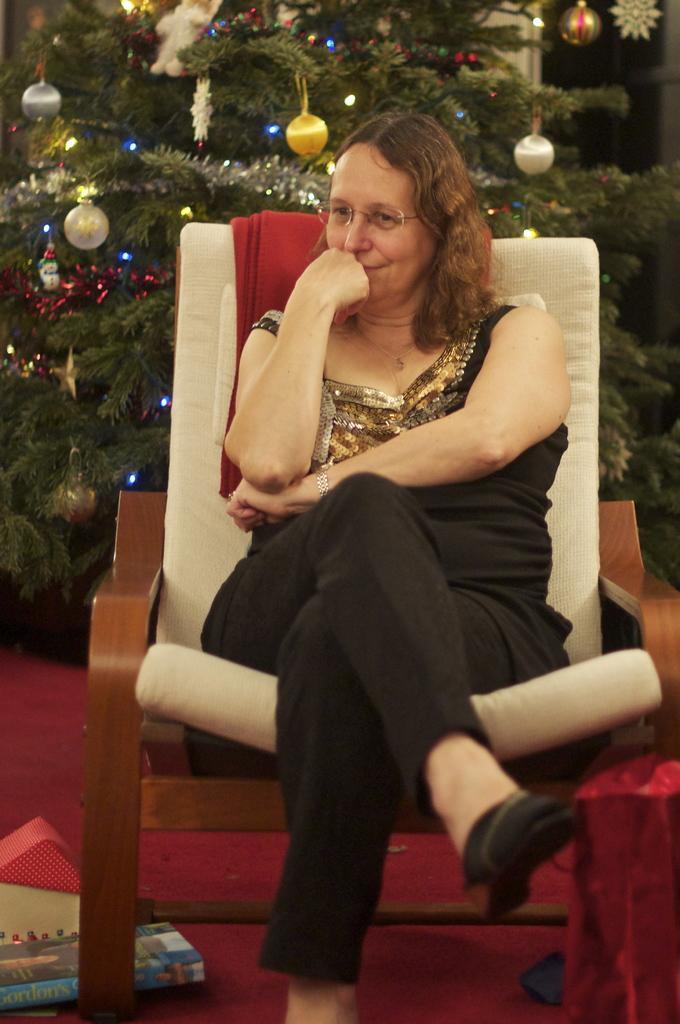How would you summarize this image in a sentence or two? In this image, we can see a person sitting on the chair in front of the Christmas tree. This person is wearing clothes and spectacles. There is a box in the bottom left of the image. 